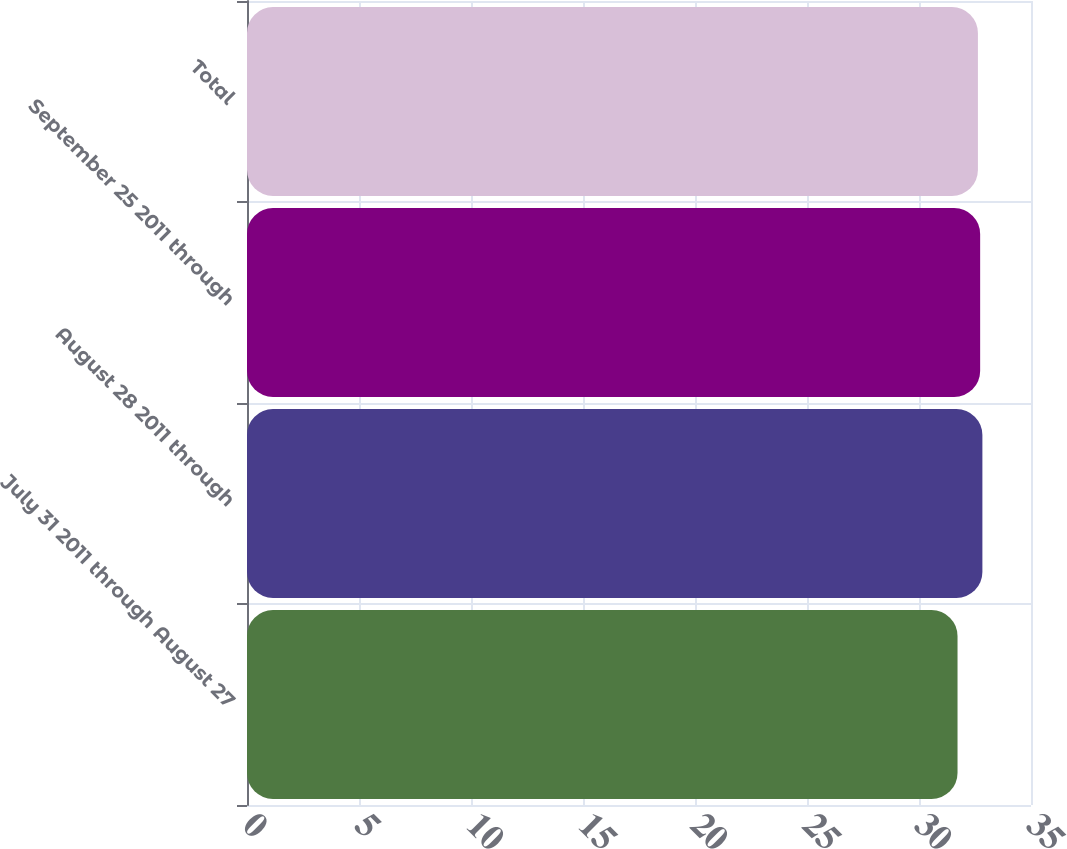Convert chart. <chart><loc_0><loc_0><loc_500><loc_500><bar_chart><fcel>July 31 2011 through August 27<fcel>August 28 2011 through<fcel>September 25 2011 through<fcel>Total<nl><fcel>31.72<fcel>32.83<fcel>32.73<fcel>32.63<nl></chart> 